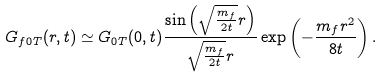<formula> <loc_0><loc_0><loc_500><loc_500>G _ { f 0 T } ( r , t ) \simeq G _ { 0 T } ( 0 , t ) \frac { \sin \left ( \sqrt { \frac { m _ { f } } { 2 t } } r \right ) } { \sqrt { \frac { m _ { f } } { 2 t } } r } \exp \left ( - \frac { m _ { f } r ^ { 2 } } { 8 t } \right ) .</formula> 